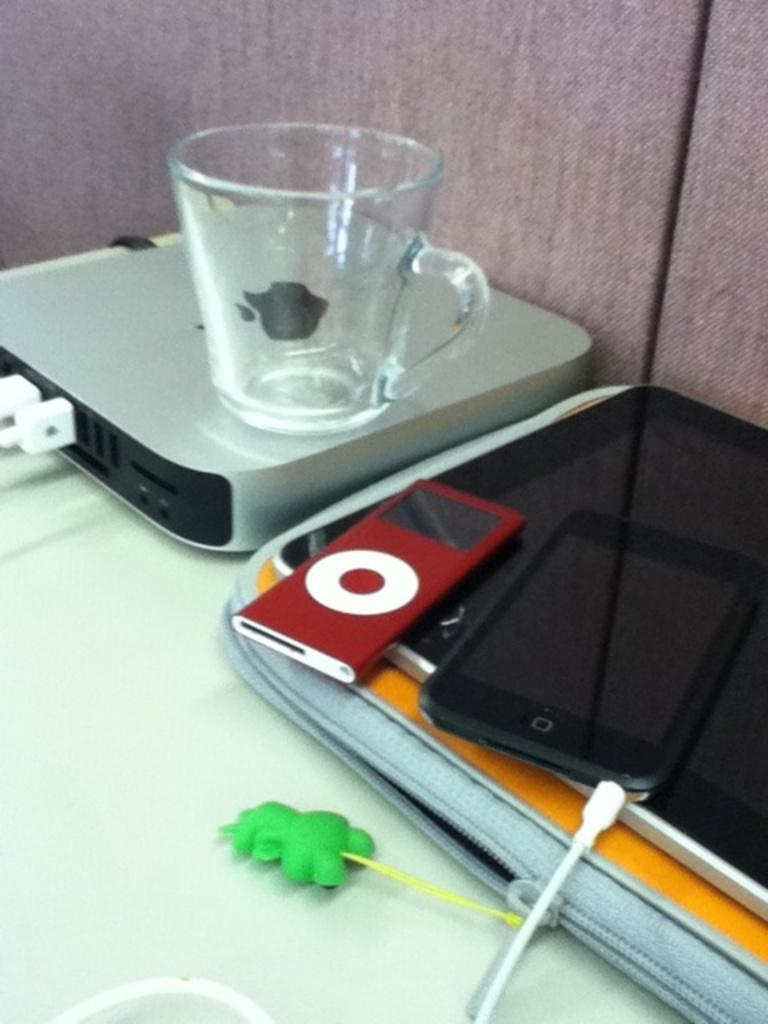What object is featured in the image that is typically used for storing apples? There is an apple box in the image. What piece of furniture is present in the image? There is a table in the image. What is on top of the table? A mobile, a bag, a key chain, and a mug are on the table. What color is the wall visible in the background of the image? There is a pink wall in the background of the image. Can you tell me how many sons are visible in the image? There are no sons present in the image. What type of tool is used to tighten or loosen bolts that can be seen in the image? There is no wrench present in the image. 